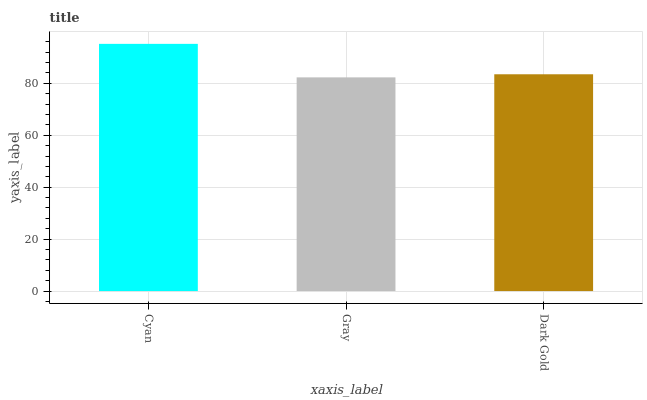Is Gray the minimum?
Answer yes or no. Yes. Is Cyan the maximum?
Answer yes or no. Yes. Is Dark Gold the minimum?
Answer yes or no. No. Is Dark Gold the maximum?
Answer yes or no. No. Is Dark Gold greater than Gray?
Answer yes or no. Yes. Is Gray less than Dark Gold?
Answer yes or no. Yes. Is Gray greater than Dark Gold?
Answer yes or no. No. Is Dark Gold less than Gray?
Answer yes or no. No. Is Dark Gold the high median?
Answer yes or no. Yes. Is Dark Gold the low median?
Answer yes or no. Yes. Is Cyan the high median?
Answer yes or no. No. Is Cyan the low median?
Answer yes or no. No. 